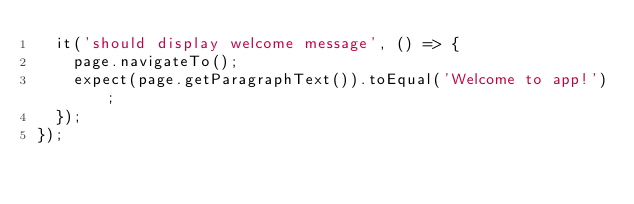<code> <loc_0><loc_0><loc_500><loc_500><_TypeScript_>  it('should display welcome message', () => {
    page.navigateTo();
    expect(page.getParagraphText()).toEqual('Welcome to app!');
  });
});
</code> 